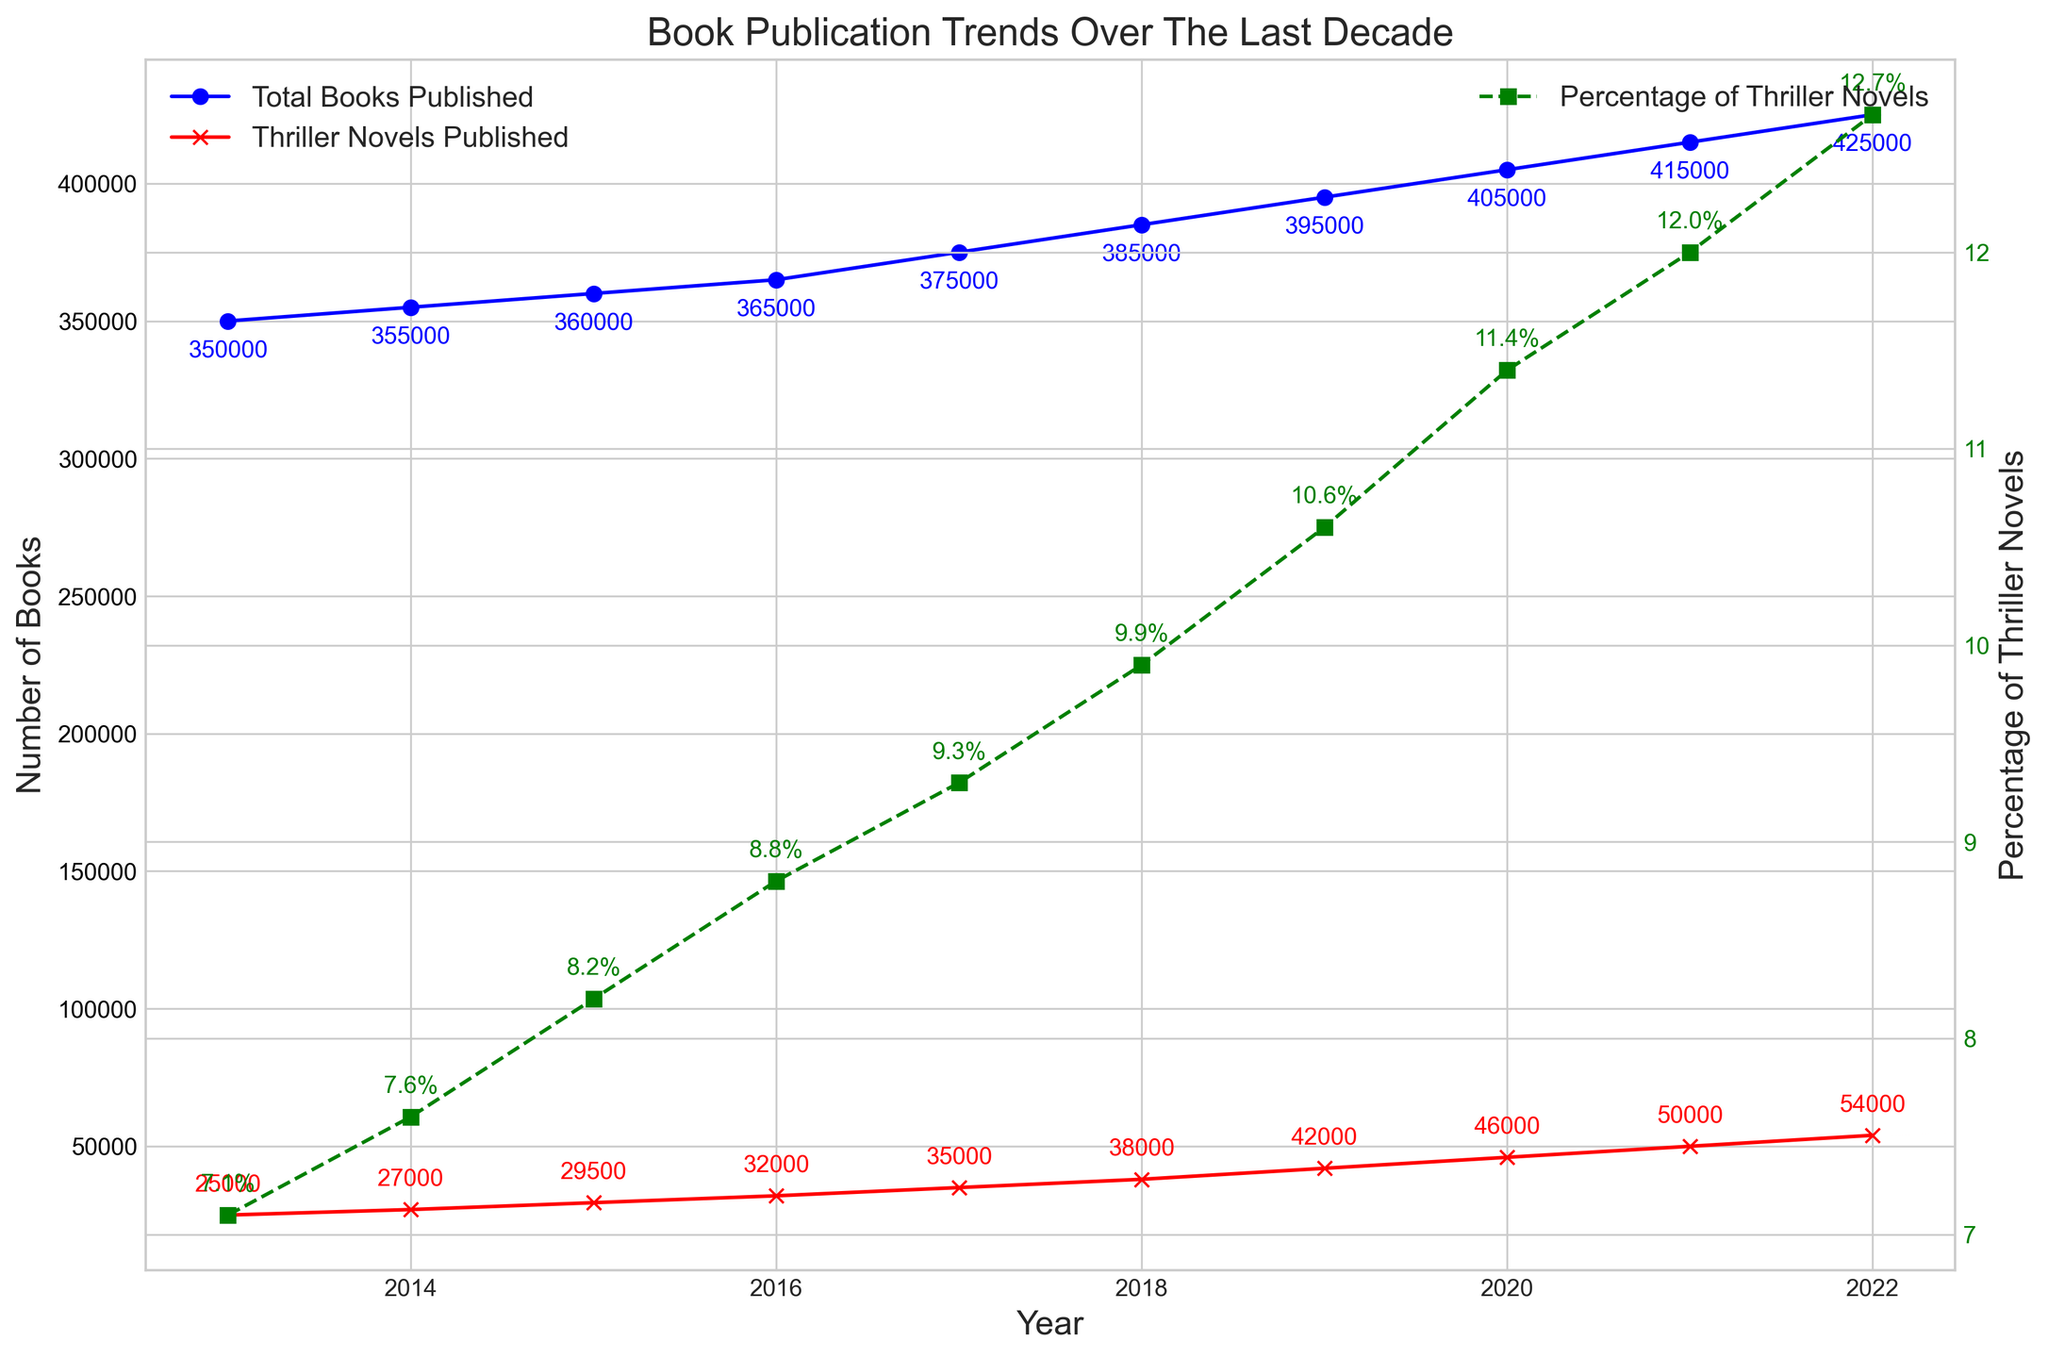how many thriller novels were published in 2021? To find the number of thriller novels published in a specific year, look at the red line marked with 'x' for that year. In 2021, the red line shows 50,000 thriller novels published.
Answer: 50,000 Which year saw the highest percentage of thriller novels? To determine the year with the highest percentage, refer to the green dashed line with 's' markers. The highest value is in 2022 at 12.7%.
Answer: 2022 By how much did the total number of books published increase from 2018 to 2019? To find the increase, subtract the total number of books in 2018 from the total number in 2019. It increased from 385,000 in 2018 to 395,000 in 2019, resulting in an increase of 10,000 books.
Answer: 10,000 Compare the number of thriller novels published in 2014 and 2020. Which year had more, and by how much? Refer to the red line marked with 'x'. In 2014, 27,000 thriller novels were published, and in 2020, 46,000 were published. The difference is 46,000 - 27,000 = 19,000 more in 2020.
Answer: 19,000 more in 2020 What's the average percentage of thriller novels published from 2019 to 2022? Calculate the average percentage for the given years: (10.6 + 11.4 + 12.0 + 12.7) / 4 = 11.675%.
Answer: 11.675% How did the percentage of thriller novels change from 2013 to 2022? Look at the green dashed line for changes in the percentages. In 2013, the percentage was 7.1%, and in 2022, it was 12.7%, an increase of 12.7 - 7.1 = 5.6 percentage points.
Answer: Increased by 5.6 percentage points Which year had the smallest number of books published, and what was the count? Refer to the blue line marked with 'o' to find the smallest value. In 2013, the smallest number of books published was 350,000.
Answer: 2013, 350,000 Between which consecutive years did the number of thriller novels published see the largest increase? Analyze the red line marked with 'x' for the biggest year-over-year jump. The largest increase is from 2019 to 2020, where it jumped from 42,000 to 46,000, an increase of 4,000.
Answer: 2019 to 2020 What was the percentage increase in the total number of books published from 2016 to 2022? Calculate the percentage increase: [(425,000 - 365,000) / 365,000] * 100 = 16.44%.
Answer: 16.44% Compare the trend lines: Are the trends for total books and thriller novels published increasing, decreasing, or stable over the decade? Both the blue line (total books) and the red line (thriller novels) show an increasing trend over the decade, with thriller novels increasing more steeply.
Answer: Increasing for both 